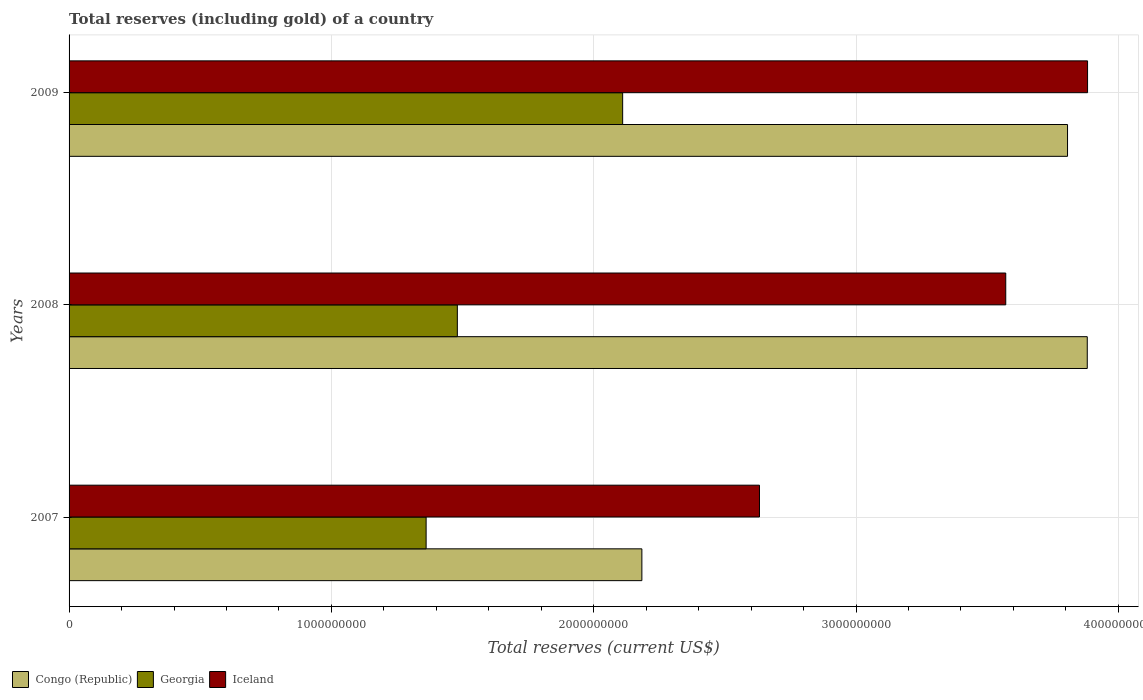How many groups of bars are there?
Offer a terse response. 3. Are the number of bars per tick equal to the number of legend labels?
Offer a terse response. Yes. How many bars are there on the 3rd tick from the bottom?
Your answer should be very brief. 3. What is the label of the 2nd group of bars from the top?
Your answer should be very brief. 2008. In how many cases, is the number of bars for a given year not equal to the number of legend labels?
Provide a succinct answer. 0. What is the total reserves (including gold) in Iceland in 2007?
Provide a short and direct response. 2.63e+09. Across all years, what is the maximum total reserves (including gold) in Iceland?
Ensure brevity in your answer.  3.88e+09. Across all years, what is the minimum total reserves (including gold) in Iceland?
Your response must be concise. 2.63e+09. In which year was the total reserves (including gold) in Iceland minimum?
Your answer should be very brief. 2007. What is the total total reserves (including gold) in Iceland in the graph?
Your response must be concise. 1.01e+1. What is the difference between the total reserves (including gold) in Iceland in 2007 and that in 2008?
Provide a short and direct response. -9.39e+08. What is the difference between the total reserves (including gold) in Iceland in 2009 and the total reserves (including gold) in Georgia in 2007?
Provide a succinct answer. 2.52e+09. What is the average total reserves (including gold) in Congo (Republic) per year?
Your response must be concise. 3.29e+09. In the year 2007, what is the difference between the total reserves (including gold) in Iceland and total reserves (including gold) in Georgia?
Keep it short and to the point. 1.27e+09. What is the ratio of the total reserves (including gold) in Georgia in 2007 to that in 2009?
Offer a very short reply. 0.64. Is the total reserves (including gold) in Iceland in 2007 less than that in 2009?
Offer a very short reply. Yes. Is the difference between the total reserves (including gold) in Iceland in 2007 and 2009 greater than the difference between the total reserves (including gold) in Georgia in 2007 and 2009?
Your response must be concise. No. What is the difference between the highest and the second highest total reserves (including gold) in Iceland?
Offer a terse response. 3.12e+08. What is the difference between the highest and the lowest total reserves (including gold) in Georgia?
Give a very brief answer. 7.49e+08. In how many years, is the total reserves (including gold) in Congo (Republic) greater than the average total reserves (including gold) in Congo (Republic) taken over all years?
Provide a short and direct response. 2. Is the sum of the total reserves (including gold) in Georgia in 2008 and 2009 greater than the maximum total reserves (including gold) in Iceland across all years?
Your answer should be very brief. No. What does the 3rd bar from the top in 2007 represents?
Provide a succinct answer. Congo (Republic). What does the 1st bar from the bottom in 2008 represents?
Your response must be concise. Congo (Republic). Are all the bars in the graph horizontal?
Provide a short and direct response. Yes. Does the graph contain any zero values?
Your answer should be very brief. No. Does the graph contain grids?
Offer a very short reply. Yes. What is the title of the graph?
Offer a terse response. Total reserves (including gold) of a country. Does "Uganda" appear as one of the legend labels in the graph?
Keep it short and to the point. No. What is the label or title of the X-axis?
Offer a terse response. Total reserves (current US$). What is the label or title of the Y-axis?
Your response must be concise. Years. What is the Total reserves (current US$) of Congo (Republic) in 2007?
Provide a short and direct response. 2.18e+09. What is the Total reserves (current US$) in Georgia in 2007?
Make the answer very short. 1.36e+09. What is the Total reserves (current US$) of Iceland in 2007?
Keep it short and to the point. 2.63e+09. What is the Total reserves (current US$) of Congo (Republic) in 2008?
Your response must be concise. 3.88e+09. What is the Total reserves (current US$) of Georgia in 2008?
Offer a very short reply. 1.48e+09. What is the Total reserves (current US$) in Iceland in 2008?
Offer a very short reply. 3.57e+09. What is the Total reserves (current US$) of Congo (Republic) in 2009?
Make the answer very short. 3.81e+09. What is the Total reserves (current US$) in Georgia in 2009?
Offer a very short reply. 2.11e+09. What is the Total reserves (current US$) in Iceland in 2009?
Offer a terse response. 3.88e+09. Across all years, what is the maximum Total reserves (current US$) in Congo (Republic)?
Keep it short and to the point. 3.88e+09. Across all years, what is the maximum Total reserves (current US$) in Georgia?
Your answer should be compact. 2.11e+09. Across all years, what is the maximum Total reserves (current US$) in Iceland?
Provide a short and direct response. 3.88e+09. Across all years, what is the minimum Total reserves (current US$) in Congo (Republic)?
Give a very brief answer. 2.18e+09. Across all years, what is the minimum Total reserves (current US$) in Georgia?
Keep it short and to the point. 1.36e+09. Across all years, what is the minimum Total reserves (current US$) of Iceland?
Your answer should be compact. 2.63e+09. What is the total Total reserves (current US$) in Congo (Republic) in the graph?
Keep it short and to the point. 9.87e+09. What is the total Total reserves (current US$) of Georgia in the graph?
Your answer should be compact. 4.95e+09. What is the total Total reserves (current US$) of Iceland in the graph?
Keep it short and to the point. 1.01e+1. What is the difference between the Total reserves (current US$) in Congo (Republic) in 2007 and that in 2008?
Offer a very short reply. -1.70e+09. What is the difference between the Total reserves (current US$) of Georgia in 2007 and that in 2008?
Make the answer very short. -1.19e+08. What is the difference between the Total reserves (current US$) in Iceland in 2007 and that in 2008?
Offer a very short reply. -9.39e+08. What is the difference between the Total reserves (current US$) of Congo (Republic) in 2007 and that in 2009?
Provide a short and direct response. -1.62e+09. What is the difference between the Total reserves (current US$) in Georgia in 2007 and that in 2009?
Your answer should be compact. -7.49e+08. What is the difference between the Total reserves (current US$) of Iceland in 2007 and that in 2009?
Keep it short and to the point. -1.25e+09. What is the difference between the Total reserves (current US$) of Congo (Republic) in 2008 and that in 2009?
Keep it short and to the point. 7.52e+07. What is the difference between the Total reserves (current US$) in Georgia in 2008 and that in 2009?
Give a very brief answer. -6.30e+08. What is the difference between the Total reserves (current US$) in Iceland in 2008 and that in 2009?
Make the answer very short. -3.12e+08. What is the difference between the Total reserves (current US$) in Congo (Republic) in 2007 and the Total reserves (current US$) in Georgia in 2008?
Offer a terse response. 7.03e+08. What is the difference between the Total reserves (current US$) in Congo (Republic) in 2007 and the Total reserves (current US$) in Iceland in 2008?
Offer a terse response. -1.39e+09. What is the difference between the Total reserves (current US$) in Georgia in 2007 and the Total reserves (current US$) in Iceland in 2008?
Keep it short and to the point. -2.21e+09. What is the difference between the Total reserves (current US$) in Congo (Republic) in 2007 and the Total reserves (current US$) in Georgia in 2009?
Your answer should be compact. 7.32e+07. What is the difference between the Total reserves (current US$) in Congo (Republic) in 2007 and the Total reserves (current US$) in Iceland in 2009?
Keep it short and to the point. -1.70e+09. What is the difference between the Total reserves (current US$) in Georgia in 2007 and the Total reserves (current US$) in Iceland in 2009?
Keep it short and to the point. -2.52e+09. What is the difference between the Total reserves (current US$) in Congo (Republic) in 2008 and the Total reserves (current US$) in Georgia in 2009?
Provide a short and direct response. 1.77e+09. What is the difference between the Total reserves (current US$) in Congo (Republic) in 2008 and the Total reserves (current US$) in Iceland in 2009?
Keep it short and to the point. -1.16e+06. What is the difference between the Total reserves (current US$) of Georgia in 2008 and the Total reserves (current US$) of Iceland in 2009?
Provide a succinct answer. -2.40e+09. What is the average Total reserves (current US$) in Congo (Republic) per year?
Offer a very short reply. 3.29e+09. What is the average Total reserves (current US$) of Georgia per year?
Your answer should be compact. 1.65e+09. What is the average Total reserves (current US$) of Iceland per year?
Provide a succinct answer. 3.36e+09. In the year 2007, what is the difference between the Total reserves (current US$) in Congo (Republic) and Total reserves (current US$) in Georgia?
Offer a terse response. 8.22e+08. In the year 2007, what is the difference between the Total reserves (current US$) in Congo (Republic) and Total reserves (current US$) in Iceland?
Offer a very short reply. -4.48e+08. In the year 2007, what is the difference between the Total reserves (current US$) of Georgia and Total reserves (current US$) of Iceland?
Provide a succinct answer. -1.27e+09. In the year 2008, what is the difference between the Total reserves (current US$) in Congo (Republic) and Total reserves (current US$) in Georgia?
Ensure brevity in your answer.  2.40e+09. In the year 2008, what is the difference between the Total reserves (current US$) of Congo (Republic) and Total reserves (current US$) of Iceland?
Provide a short and direct response. 3.11e+08. In the year 2008, what is the difference between the Total reserves (current US$) of Georgia and Total reserves (current US$) of Iceland?
Offer a very short reply. -2.09e+09. In the year 2009, what is the difference between the Total reserves (current US$) in Congo (Republic) and Total reserves (current US$) in Georgia?
Your response must be concise. 1.70e+09. In the year 2009, what is the difference between the Total reserves (current US$) in Congo (Republic) and Total reserves (current US$) in Iceland?
Keep it short and to the point. -7.64e+07. In the year 2009, what is the difference between the Total reserves (current US$) of Georgia and Total reserves (current US$) of Iceland?
Make the answer very short. -1.77e+09. What is the ratio of the Total reserves (current US$) of Congo (Republic) in 2007 to that in 2008?
Provide a succinct answer. 0.56. What is the ratio of the Total reserves (current US$) in Georgia in 2007 to that in 2008?
Your answer should be compact. 0.92. What is the ratio of the Total reserves (current US$) in Iceland in 2007 to that in 2008?
Keep it short and to the point. 0.74. What is the ratio of the Total reserves (current US$) in Congo (Republic) in 2007 to that in 2009?
Your response must be concise. 0.57. What is the ratio of the Total reserves (current US$) of Georgia in 2007 to that in 2009?
Your answer should be very brief. 0.65. What is the ratio of the Total reserves (current US$) of Iceland in 2007 to that in 2009?
Your answer should be very brief. 0.68. What is the ratio of the Total reserves (current US$) of Congo (Republic) in 2008 to that in 2009?
Give a very brief answer. 1.02. What is the ratio of the Total reserves (current US$) of Georgia in 2008 to that in 2009?
Ensure brevity in your answer.  0.7. What is the ratio of the Total reserves (current US$) of Iceland in 2008 to that in 2009?
Provide a succinct answer. 0.92. What is the difference between the highest and the second highest Total reserves (current US$) of Congo (Republic)?
Your answer should be compact. 7.52e+07. What is the difference between the highest and the second highest Total reserves (current US$) in Georgia?
Provide a succinct answer. 6.30e+08. What is the difference between the highest and the second highest Total reserves (current US$) in Iceland?
Provide a short and direct response. 3.12e+08. What is the difference between the highest and the lowest Total reserves (current US$) in Congo (Republic)?
Keep it short and to the point. 1.70e+09. What is the difference between the highest and the lowest Total reserves (current US$) in Georgia?
Your answer should be compact. 7.49e+08. What is the difference between the highest and the lowest Total reserves (current US$) of Iceland?
Your answer should be very brief. 1.25e+09. 